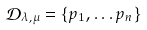Convert formula to latex. <formula><loc_0><loc_0><loc_500><loc_500>{ \mathcal { D } } _ { \lambda , \mu } = \{ p _ { 1 } , \dots p _ { n } \}</formula> 